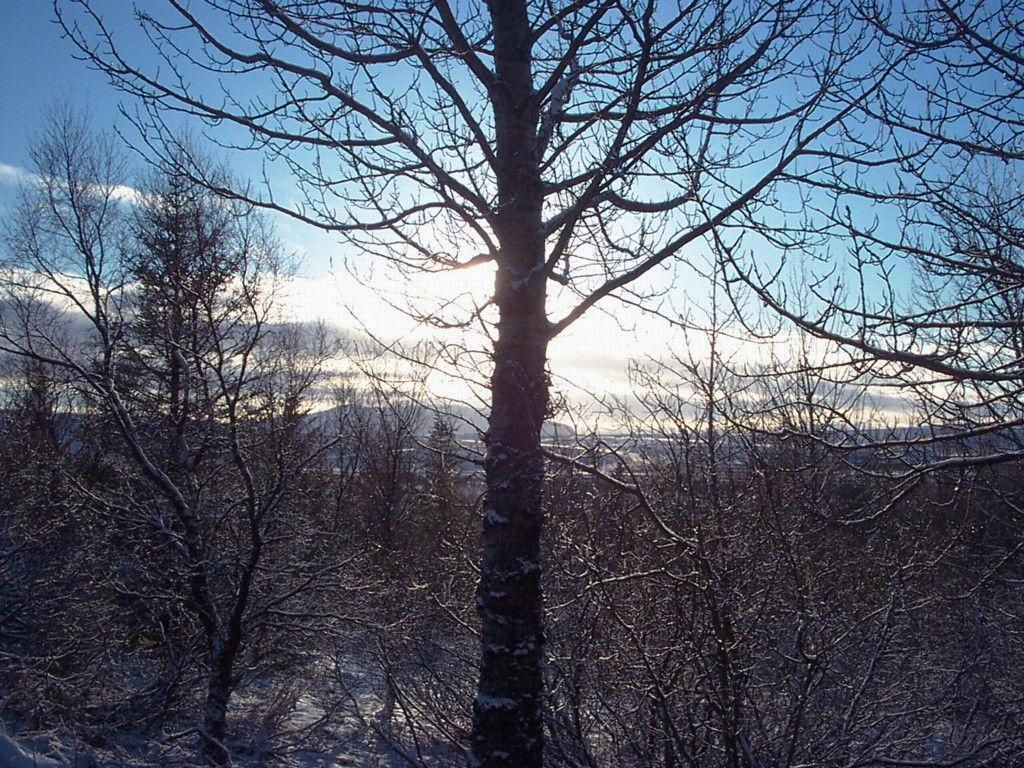What type of vegetation can be seen in the image? There is a group of trees in the image. What can be seen in the distance behind the trees? There are hills visible in the background of the image. What part of the natural environment is visible in the image? The sky is visible in the image. How would you describe the sky in the image? The sky appears to be cloudy. How many rabbits can be seen whistling in the image? There are no rabbits or whistling sounds present in the image. 